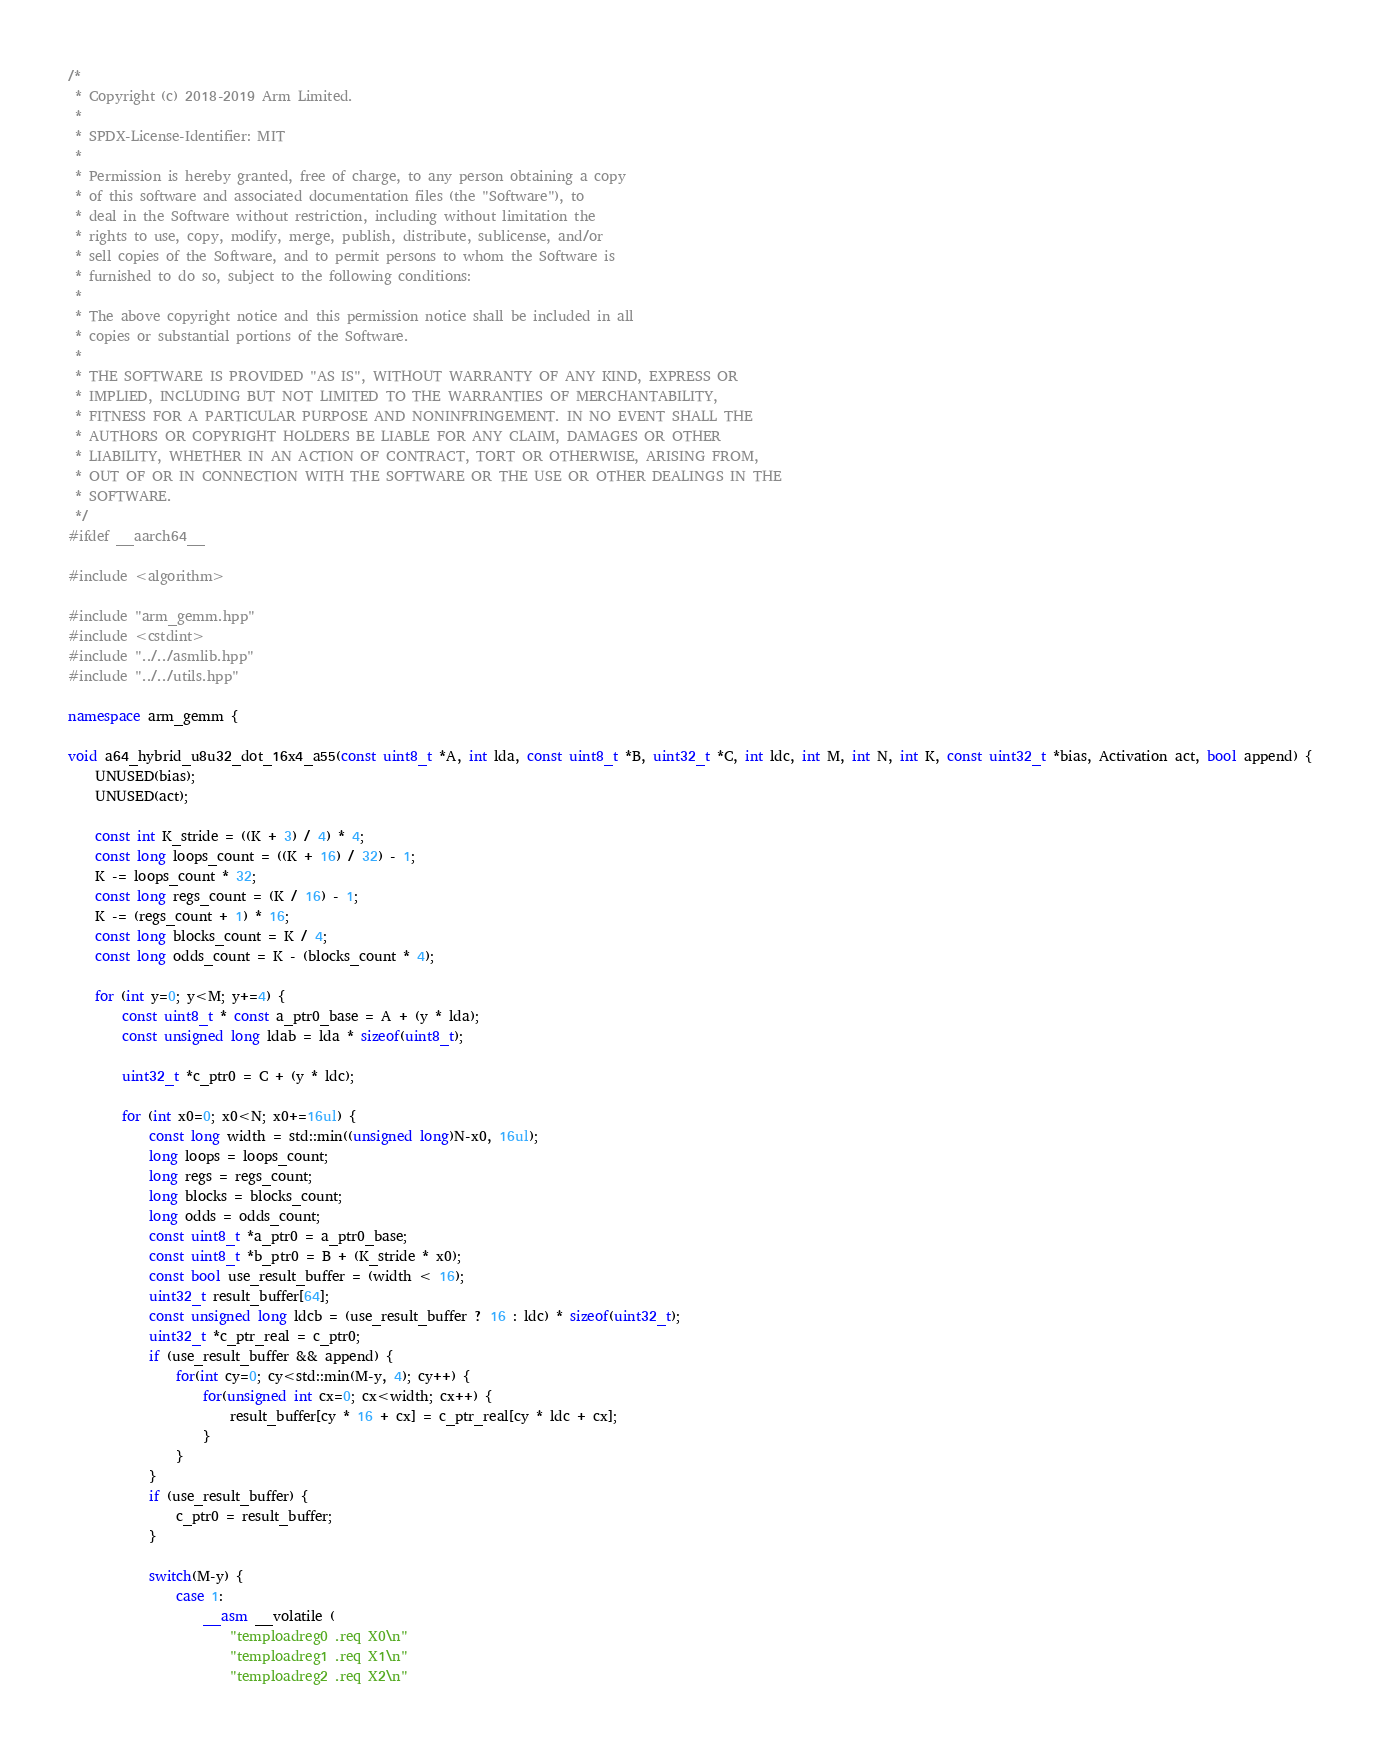<code> <loc_0><loc_0><loc_500><loc_500><_C++_>/*
 * Copyright (c) 2018-2019 Arm Limited.
 *
 * SPDX-License-Identifier: MIT
 *
 * Permission is hereby granted, free of charge, to any person obtaining a copy
 * of this software and associated documentation files (the "Software"), to
 * deal in the Software without restriction, including without limitation the
 * rights to use, copy, modify, merge, publish, distribute, sublicense, and/or
 * sell copies of the Software, and to permit persons to whom the Software is
 * furnished to do so, subject to the following conditions:
 *
 * The above copyright notice and this permission notice shall be included in all
 * copies or substantial portions of the Software.
 *
 * THE SOFTWARE IS PROVIDED "AS IS", WITHOUT WARRANTY OF ANY KIND, EXPRESS OR
 * IMPLIED, INCLUDING BUT NOT LIMITED TO THE WARRANTIES OF MERCHANTABILITY,
 * FITNESS FOR A PARTICULAR PURPOSE AND NONINFRINGEMENT. IN NO EVENT SHALL THE
 * AUTHORS OR COPYRIGHT HOLDERS BE LIABLE FOR ANY CLAIM, DAMAGES OR OTHER
 * LIABILITY, WHETHER IN AN ACTION OF CONTRACT, TORT OR OTHERWISE, ARISING FROM,
 * OUT OF OR IN CONNECTION WITH THE SOFTWARE OR THE USE OR OTHER DEALINGS IN THE
 * SOFTWARE.
 */
#ifdef __aarch64__

#include <algorithm>

#include "arm_gemm.hpp"
#include <cstdint>
#include "../../asmlib.hpp"
#include "../../utils.hpp"

namespace arm_gemm {

void a64_hybrid_u8u32_dot_16x4_a55(const uint8_t *A, int lda, const uint8_t *B, uint32_t *C, int ldc, int M, int N, int K, const uint32_t *bias, Activation act, bool append) {
    UNUSED(bias);
    UNUSED(act);

    const int K_stride = ((K + 3) / 4) * 4;
    const long loops_count = ((K + 16) / 32) - 1;
    K -= loops_count * 32;
    const long regs_count = (K / 16) - 1;
    K -= (regs_count + 1) * 16;
    const long blocks_count = K / 4;
    const long odds_count = K - (blocks_count * 4);

    for (int y=0; y<M; y+=4) {
        const uint8_t * const a_ptr0_base = A + (y * lda);
        const unsigned long ldab = lda * sizeof(uint8_t);

        uint32_t *c_ptr0 = C + (y * ldc);

        for (int x0=0; x0<N; x0+=16ul) {
            const long width = std::min((unsigned long)N-x0, 16ul);
            long loops = loops_count;
            long regs = regs_count;
            long blocks = blocks_count;
            long odds = odds_count;
            const uint8_t *a_ptr0 = a_ptr0_base;
            const uint8_t *b_ptr0 = B + (K_stride * x0);
            const bool use_result_buffer = (width < 16);
            uint32_t result_buffer[64];
            const unsigned long ldcb = (use_result_buffer ? 16 : ldc) * sizeof(uint32_t);
            uint32_t *c_ptr_real = c_ptr0;
            if (use_result_buffer && append) {
                for(int cy=0; cy<std::min(M-y, 4); cy++) {
                    for(unsigned int cx=0; cx<width; cx++) {
                        result_buffer[cy * 16 + cx] = c_ptr_real[cy * ldc + cx];
                    }
                }
            }
            if (use_result_buffer) {
                c_ptr0 = result_buffer;
            }

            switch(M-y) {
                case 1:
                    __asm __volatile (
                        "temploadreg0 .req X0\n"
                        "temploadreg1 .req X1\n"
                        "temploadreg2 .req X2\n"</code> 